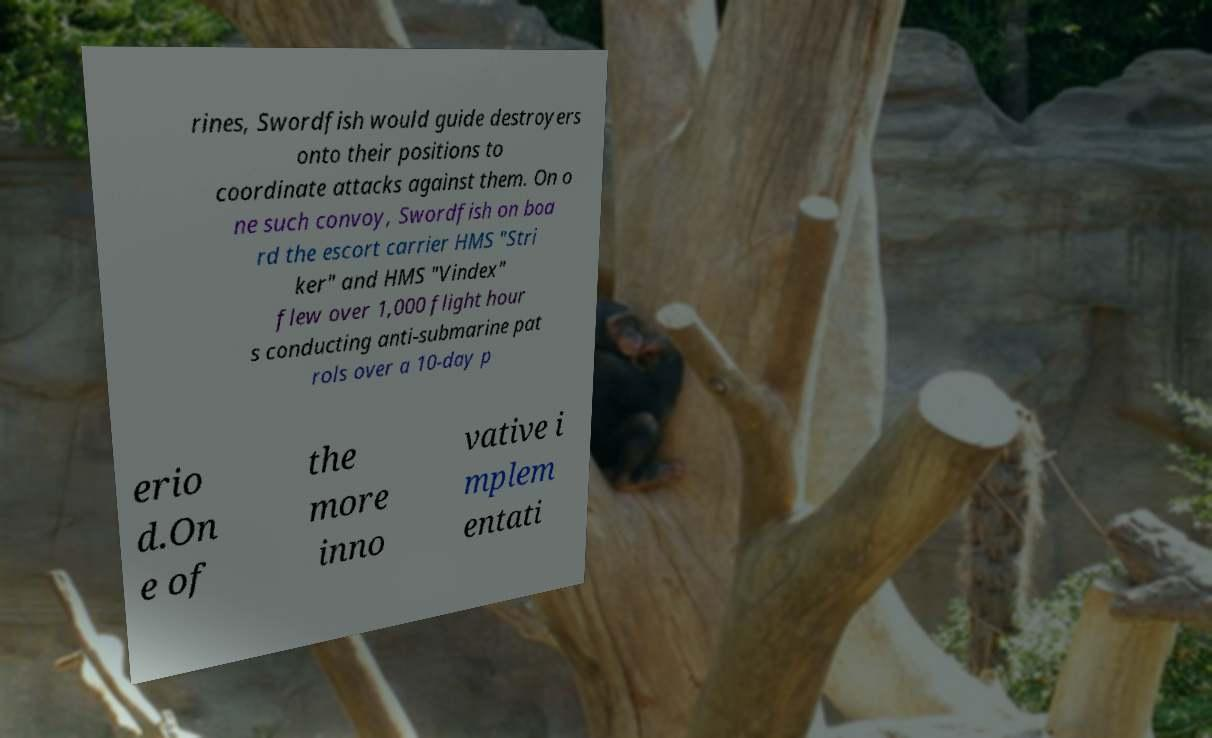Please read and relay the text visible in this image. What does it say? rines, Swordfish would guide destroyers onto their positions to coordinate attacks against them. On o ne such convoy, Swordfish on boa rd the escort carrier HMS "Stri ker" and HMS "Vindex" flew over 1,000 flight hour s conducting anti-submarine pat rols over a 10-day p erio d.On e of the more inno vative i mplem entati 